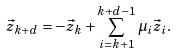Convert formula to latex. <formula><loc_0><loc_0><loc_500><loc_500>\vec { z } _ { k + d } = - \vec { z } _ { k } + \sum _ { i = k + 1 } ^ { k + d - 1 } \mu _ { i } \vec { z } _ { i } .</formula> 